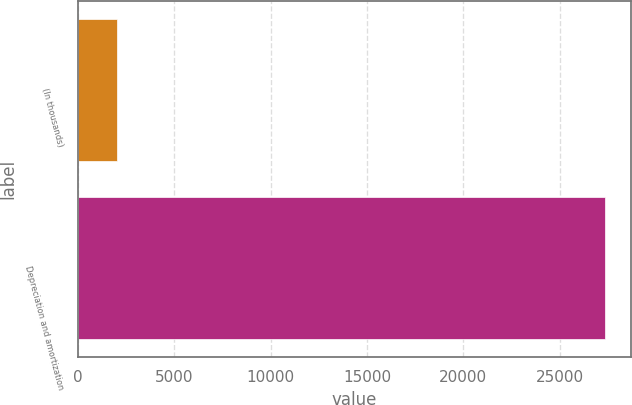Convert chart. <chart><loc_0><loc_0><loc_500><loc_500><bar_chart><fcel>(In thousands)<fcel>Depreciation and amortization<nl><fcel>2016<fcel>27360<nl></chart> 